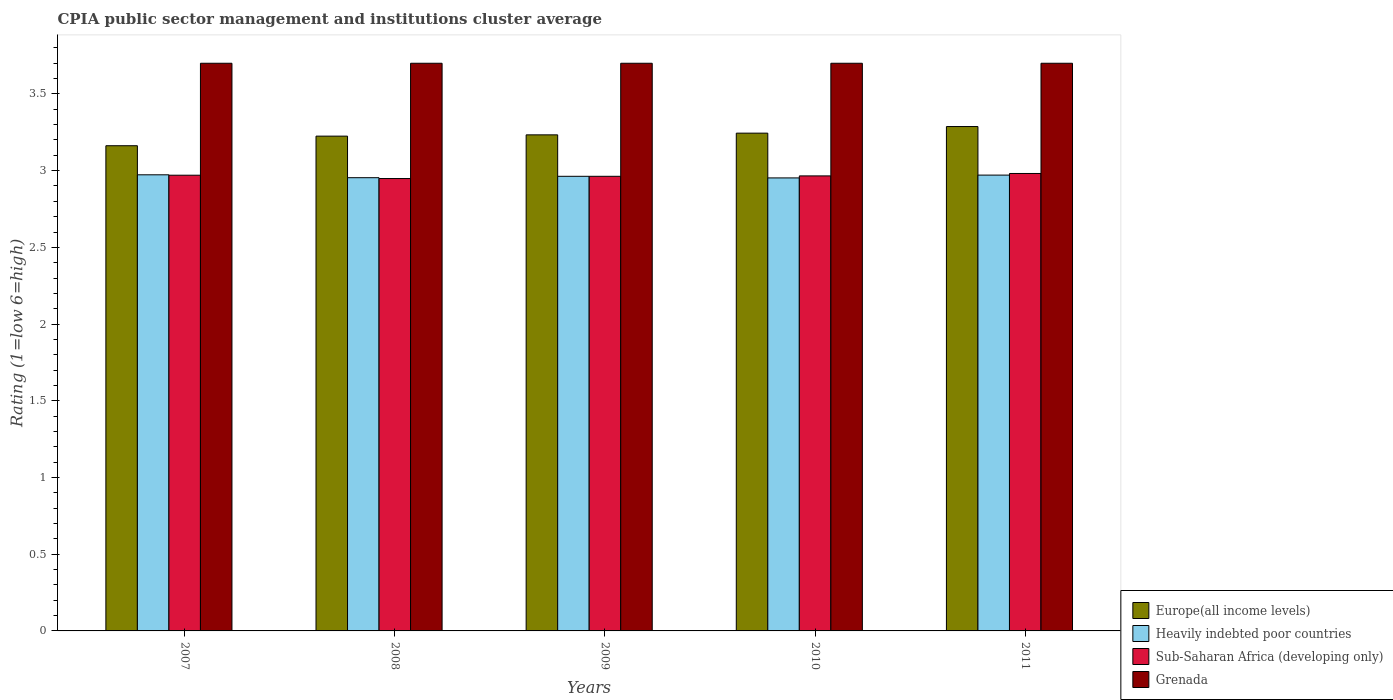How many different coloured bars are there?
Provide a short and direct response. 4. How many groups of bars are there?
Provide a short and direct response. 5. How many bars are there on the 3rd tick from the left?
Your response must be concise. 4. How many bars are there on the 3rd tick from the right?
Provide a succinct answer. 4. In how many cases, is the number of bars for a given year not equal to the number of legend labels?
Offer a terse response. 0. What is the CPIA rating in Europe(all income levels) in 2008?
Provide a short and direct response. 3.23. Across all years, what is the maximum CPIA rating in Sub-Saharan Africa (developing only)?
Keep it short and to the point. 2.98. Across all years, what is the minimum CPIA rating in Heavily indebted poor countries?
Ensure brevity in your answer.  2.95. In which year was the CPIA rating in Sub-Saharan Africa (developing only) maximum?
Your answer should be very brief. 2011. What is the total CPIA rating in Europe(all income levels) in the graph?
Your answer should be very brief. 16.15. What is the difference between the CPIA rating in Grenada in 2007 and the CPIA rating in Europe(all income levels) in 2009?
Your answer should be compact. 0.47. What is the average CPIA rating in Heavily indebted poor countries per year?
Offer a very short reply. 2.96. In the year 2009, what is the difference between the CPIA rating in Sub-Saharan Africa (developing only) and CPIA rating in Europe(all income levels)?
Offer a terse response. -0.27. Is the CPIA rating in Grenada in 2007 less than that in 2011?
Provide a succinct answer. No. Is the difference between the CPIA rating in Sub-Saharan Africa (developing only) in 2007 and 2009 greater than the difference between the CPIA rating in Europe(all income levels) in 2007 and 2009?
Ensure brevity in your answer.  Yes. What is the difference between the highest and the second highest CPIA rating in Sub-Saharan Africa (developing only)?
Keep it short and to the point. 0.01. What is the difference between the highest and the lowest CPIA rating in Grenada?
Offer a terse response. 0. In how many years, is the CPIA rating in Europe(all income levels) greater than the average CPIA rating in Europe(all income levels) taken over all years?
Offer a terse response. 3. Is it the case that in every year, the sum of the CPIA rating in Heavily indebted poor countries and CPIA rating in Sub-Saharan Africa (developing only) is greater than the sum of CPIA rating in Europe(all income levels) and CPIA rating in Grenada?
Make the answer very short. No. What does the 4th bar from the left in 2008 represents?
Make the answer very short. Grenada. What does the 1st bar from the right in 2008 represents?
Give a very brief answer. Grenada. Is it the case that in every year, the sum of the CPIA rating in Grenada and CPIA rating in Europe(all income levels) is greater than the CPIA rating in Sub-Saharan Africa (developing only)?
Provide a succinct answer. Yes. How many years are there in the graph?
Your answer should be very brief. 5. What is the difference between two consecutive major ticks on the Y-axis?
Make the answer very short. 0.5. How are the legend labels stacked?
Give a very brief answer. Vertical. What is the title of the graph?
Keep it short and to the point. CPIA public sector management and institutions cluster average. Does "OECD members" appear as one of the legend labels in the graph?
Provide a short and direct response. No. What is the label or title of the X-axis?
Offer a terse response. Years. What is the label or title of the Y-axis?
Ensure brevity in your answer.  Rating (1=low 6=high). What is the Rating (1=low 6=high) in Europe(all income levels) in 2007?
Your answer should be compact. 3.16. What is the Rating (1=low 6=high) in Heavily indebted poor countries in 2007?
Your answer should be compact. 2.97. What is the Rating (1=low 6=high) in Sub-Saharan Africa (developing only) in 2007?
Provide a succinct answer. 2.97. What is the Rating (1=low 6=high) in Grenada in 2007?
Your response must be concise. 3.7. What is the Rating (1=low 6=high) of Europe(all income levels) in 2008?
Offer a very short reply. 3.23. What is the Rating (1=low 6=high) of Heavily indebted poor countries in 2008?
Ensure brevity in your answer.  2.95. What is the Rating (1=low 6=high) of Sub-Saharan Africa (developing only) in 2008?
Your answer should be compact. 2.95. What is the Rating (1=low 6=high) of Europe(all income levels) in 2009?
Ensure brevity in your answer.  3.23. What is the Rating (1=low 6=high) in Heavily indebted poor countries in 2009?
Provide a short and direct response. 2.96. What is the Rating (1=low 6=high) of Sub-Saharan Africa (developing only) in 2009?
Give a very brief answer. 2.96. What is the Rating (1=low 6=high) of Grenada in 2009?
Keep it short and to the point. 3.7. What is the Rating (1=low 6=high) of Europe(all income levels) in 2010?
Provide a succinct answer. 3.24. What is the Rating (1=low 6=high) of Heavily indebted poor countries in 2010?
Your response must be concise. 2.95. What is the Rating (1=low 6=high) of Sub-Saharan Africa (developing only) in 2010?
Provide a succinct answer. 2.97. What is the Rating (1=low 6=high) of Europe(all income levels) in 2011?
Your response must be concise. 3.29. What is the Rating (1=low 6=high) of Heavily indebted poor countries in 2011?
Offer a terse response. 2.97. What is the Rating (1=low 6=high) of Sub-Saharan Africa (developing only) in 2011?
Make the answer very short. 2.98. What is the Rating (1=low 6=high) in Grenada in 2011?
Ensure brevity in your answer.  3.7. Across all years, what is the maximum Rating (1=low 6=high) in Europe(all income levels)?
Make the answer very short. 3.29. Across all years, what is the maximum Rating (1=low 6=high) in Heavily indebted poor countries?
Provide a short and direct response. 2.97. Across all years, what is the maximum Rating (1=low 6=high) in Sub-Saharan Africa (developing only)?
Ensure brevity in your answer.  2.98. Across all years, what is the minimum Rating (1=low 6=high) of Europe(all income levels)?
Ensure brevity in your answer.  3.16. Across all years, what is the minimum Rating (1=low 6=high) of Heavily indebted poor countries?
Ensure brevity in your answer.  2.95. Across all years, what is the minimum Rating (1=low 6=high) of Sub-Saharan Africa (developing only)?
Your response must be concise. 2.95. Across all years, what is the minimum Rating (1=low 6=high) in Grenada?
Ensure brevity in your answer.  3.7. What is the total Rating (1=low 6=high) of Europe(all income levels) in the graph?
Give a very brief answer. 16.15. What is the total Rating (1=low 6=high) of Heavily indebted poor countries in the graph?
Offer a terse response. 14.81. What is the total Rating (1=low 6=high) of Sub-Saharan Africa (developing only) in the graph?
Keep it short and to the point. 14.83. What is the difference between the Rating (1=low 6=high) of Europe(all income levels) in 2007 and that in 2008?
Your answer should be very brief. -0.06. What is the difference between the Rating (1=low 6=high) in Heavily indebted poor countries in 2007 and that in 2008?
Provide a succinct answer. 0.02. What is the difference between the Rating (1=low 6=high) of Sub-Saharan Africa (developing only) in 2007 and that in 2008?
Provide a succinct answer. 0.02. What is the difference between the Rating (1=low 6=high) of Grenada in 2007 and that in 2008?
Keep it short and to the point. 0. What is the difference between the Rating (1=low 6=high) of Europe(all income levels) in 2007 and that in 2009?
Provide a succinct answer. -0.07. What is the difference between the Rating (1=low 6=high) of Heavily indebted poor countries in 2007 and that in 2009?
Provide a short and direct response. 0.01. What is the difference between the Rating (1=low 6=high) in Sub-Saharan Africa (developing only) in 2007 and that in 2009?
Provide a succinct answer. 0.01. What is the difference between the Rating (1=low 6=high) in Grenada in 2007 and that in 2009?
Make the answer very short. 0. What is the difference between the Rating (1=low 6=high) of Europe(all income levels) in 2007 and that in 2010?
Provide a short and direct response. -0.08. What is the difference between the Rating (1=low 6=high) in Heavily indebted poor countries in 2007 and that in 2010?
Give a very brief answer. 0.02. What is the difference between the Rating (1=low 6=high) of Sub-Saharan Africa (developing only) in 2007 and that in 2010?
Offer a very short reply. 0. What is the difference between the Rating (1=low 6=high) in Grenada in 2007 and that in 2010?
Provide a short and direct response. 0. What is the difference between the Rating (1=low 6=high) in Europe(all income levels) in 2007 and that in 2011?
Offer a very short reply. -0.12. What is the difference between the Rating (1=low 6=high) of Heavily indebted poor countries in 2007 and that in 2011?
Provide a short and direct response. 0. What is the difference between the Rating (1=low 6=high) in Sub-Saharan Africa (developing only) in 2007 and that in 2011?
Make the answer very short. -0.01. What is the difference between the Rating (1=low 6=high) of Europe(all income levels) in 2008 and that in 2009?
Ensure brevity in your answer.  -0.01. What is the difference between the Rating (1=low 6=high) in Heavily indebted poor countries in 2008 and that in 2009?
Your answer should be compact. -0.01. What is the difference between the Rating (1=low 6=high) in Sub-Saharan Africa (developing only) in 2008 and that in 2009?
Your answer should be very brief. -0.01. What is the difference between the Rating (1=low 6=high) in Grenada in 2008 and that in 2009?
Give a very brief answer. 0. What is the difference between the Rating (1=low 6=high) in Europe(all income levels) in 2008 and that in 2010?
Offer a terse response. -0.02. What is the difference between the Rating (1=low 6=high) of Heavily indebted poor countries in 2008 and that in 2010?
Offer a terse response. 0. What is the difference between the Rating (1=low 6=high) of Sub-Saharan Africa (developing only) in 2008 and that in 2010?
Provide a short and direct response. -0.02. What is the difference between the Rating (1=low 6=high) in Europe(all income levels) in 2008 and that in 2011?
Offer a very short reply. -0.06. What is the difference between the Rating (1=low 6=high) in Heavily indebted poor countries in 2008 and that in 2011?
Ensure brevity in your answer.  -0.02. What is the difference between the Rating (1=low 6=high) in Sub-Saharan Africa (developing only) in 2008 and that in 2011?
Make the answer very short. -0.03. What is the difference between the Rating (1=low 6=high) in Grenada in 2008 and that in 2011?
Provide a succinct answer. 0. What is the difference between the Rating (1=low 6=high) in Europe(all income levels) in 2009 and that in 2010?
Your response must be concise. -0.01. What is the difference between the Rating (1=low 6=high) in Heavily indebted poor countries in 2009 and that in 2010?
Ensure brevity in your answer.  0.01. What is the difference between the Rating (1=low 6=high) in Sub-Saharan Africa (developing only) in 2009 and that in 2010?
Ensure brevity in your answer.  -0. What is the difference between the Rating (1=low 6=high) in Grenada in 2009 and that in 2010?
Ensure brevity in your answer.  0. What is the difference between the Rating (1=low 6=high) in Europe(all income levels) in 2009 and that in 2011?
Offer a terse response. -0.05. What is the difference between the Rating (1=low 6=high) of Heavily indebted poor countries in 2009 and that in 2011?
Keep it short and to the point. -0.01. What is the difference between the Rating (1=low 6=high) of Sub-Saharan Africa (developing only) in 2009 and that in 2011?
Offer a terse response. -0.02. What is the difference between the Rating (1=low 6=high) of Europe(all income levels) in 2010 and that in 2011?
Ensure brevity in your answer.  -0.04. What is the difference between the Rating (1=low 6=high) of Heavily indebted poor countries in 2010 and that in 2011?
Offer a very short reply. -0.02. What is the difference between the Rating (1=low 6=high) of Sub-Saharan Africa (developing only) in 2010 and that in 2011?
Offer a very short reply. -0.02. What is the difference between the Rating (1=low 6=high) of Europe(all income levels) in 2007 and the Rating (1=low 6=high) of Heavily indebted poor countries in 2008?
Offer a very short reply. 0.21. What is the difference between the Rating (1=low 6=high) of Europe(all income levels) in 2007 and the Rating (1=low 6=high) of Sub-Saharan Africa (developing only) in 2008?
Offer a terse response. 0.21. What is the difference between the Rating (1=low 6=high) in Europe(all income levels) in 2007 and the Rating (1=low 6=high) in Grenada in 2008?
Ensure brevity in your answer.  -0.54. What is the difference between the Rating (1=low 6=high) in Heavily indebted poor countries in 2007 and the Rating (1=low 6=high) in Sub-Saharan Africa (developing only) in 2008?
Keep it short and to the point. 0.02. What is the difference between the Rating (1=low 6=high) of Heavily indebted poor countries in 2007 and the Rating (1=low 6=high) of Grenada in 2008?
Give a very brief answer. -0.73. What is the difference between the Rating (1=low 6=high) in Sub-Saharan Africa (developing only) in 2007 and the Rating (1=low 6=high) in Grenada in 2008?
Your answer should be very brief. -0.73. What is the difference between the Rating (1=low 6=high) in Europe(all income levels) in 2007 and the Rating (1=low 6=high) in Heavily indebted poor countries in 2009?
Give a very brief answer. 0.2. What is the difference between the Rating (1=low 6=high) in Europe(all income levels) in 2007 and the Rating (1=low 6=high) in Sub-Saharan Africa (developing only) in 2009?
Provide a short and direct response. 0.2. What is the difference between the Rating (1=low 6=high) of Europe(all income levels) in 2007 and the Rating (1=low 6=high) of Grenada in 2009?
Your answer should be very brief. -0.54. What is the difference between the Rating (1=low 6=high) of Heavily indebted poor countries in 2007 and the Rating (1=low 6=high) of Sub-Saharan Africa (developing only) in 2009?
Your response must be concise. 0.01. What is the difference between the Rating (1=low 6=high) in Heavily indebted poor countries in 2007 and the Rating (1=low 6=high) in Grenada in 2009?
Ensure brevity in your answer.  -0.73. What is the difference between the Rating (1=low 6=high) in Sub-Saharan Africa (developing only) in 2007 and the Rating (1=low 6=high) in Grenada in 2009?
Give a very brief answer. -0.73. What is the difference between the Rating (1=low 6=high) of Europe(all income levels) in 2007 and the Rating (1=low 6=high) of Heavily indebted poor countries in 2010?
Provide a succinct answer. 0.21. What is the difference between the Rating (1=low 6=high) of Europe(all income levels) in 2007 and the Rating (1=low 6=high) of Sub-Saharan Africa (developing only) in 2010?
Offer a very short reply. 0.2. What is the difference between the Rating (1=low 6=high) of Europe(all income levels) in 2007 and the Rating (1=low 6=high) of Grenada in 2010?
Your response must be concise. -0.54. What is the difference between the Rating (1=low 6=high) in Heavily indebted poor countries in 2007 and the Rating (1=low 6=high) in Sub-Saharan Africa (developing only) in 2010?
Give a very brief answer. 0.01. What is the difference between the Rating (1=low 6=high) in Heavily indebted poor countries in 2007 and the Rating (1=low 6=high) in Grenada in 2010?
Your response must be concise. -0.73. What is the difference between the Rating (1=low 6=high) of Sub-Saharan Africa (developing only) in 2007 and the Rating (1=low 6=high) of Grenada in 2010?
Your answer should be very brief. -0.73. What is the difference between the Rating (1=low 6=high) of Europe(all income levels) in 2007 and the Rating (1=low 6=high) of Heavily indebted poor countries in 2011?
Ensure brevity in your answer.  0.19. What is the difference between the Rating (1=low 6=high) of Europe(all income levels) in 2007 and the Rating (1=low 6=high) of Sub-Saharan Africa (developing only) in 2011?
Provide a short and direct response. 0.18. What is the difference between the Rating (1=low 6=high) in Europe(all income levels) in 2007 and the Rating (1=low 6=high) in Grenada in 2011?
Give a very brief answer. -0.54. What is the difference between the Rating (1=low 6=high) in Heavily indebted poor countries in 2007 and the Rating (1=low 6=high) in Sub-Saharan Africa (developing only) in 2011?
Offer a terse response. -0.01. What is the difference between the Rating (1=low 6=high) in Heavily indebted poor countries in 2007 and the Rating (1=low 6=high) in Grenada in 2011?
Provide a short and direct response. -0.73. What is the difference between the Rating (1=low 6=high) of Sub-Saharan Africa (developing only) in 2007 and the Rating (1=low 6=high) of Grenada in 2011?
Provide a short and direct response. -0.73. What is the difference between the Rating (1=low 6=high) in Europe(all income levels) in 2008 and the Rating (1=low 6=high) in Heavily indebted poor countries in 2009?
Offer a very short reply. 0.26. What is the difference between the Rating (1=low 6=high) of Europe(all income levels) in 2008 and the Rating (1=low 6=high) of Sub-Saharan Africa (developing only) in 2009?
Provide a succinct answer. 0.26. What is the difference between the Rating (1=low 6=high) of Europe(all income levels) in 2008 and the Rating (1=low 6=high) of Grenada in 2009?
Keep it short and to the point. -0.47. What is the difference between the Rating (1=low 6=high) in Heavily indebted poor countries in 2008 and the Rating (1=low 6=high) in Sub-Saharan Africa (developing only) in 2009?
Offer a terse response. -0.01. What is the difference between the Rating (1=low 6=high) in Heavily indebted poor countries in 2008 and the Rating (1=low 6=high) in Grenada in 2009?
Your answer should be very brief. -0.75. What is the difference between the Rating (1=low 6=high) of Sub-Saharan Africa (developing only) in 2008 and the Rating (1=low 6=high) of Grenada in 2009?
Make the answer very short. -0.75. What is the difference between the Rating (1=low 6=high) of Europe(all income levels) in 2008 and the Rating (1=low 6=high) of Heavily indebted poor countries in 2010?
Your answer should be very brief. 0.27. What is the difference between the Rating (1=low 6=high) of Europe(all income levels) in 2008 and the Rating (1=low 6=high) of Sub-Saharan Africa (developing only) in 2010?
Keep it short and to the point. 0.26. What is the difference between the Rating (1=low 6=high) of Europe(all income levels) in 2008 and the Rating (1=low 6=high) of Grenada in 2010?
Provide a succinct answer. -0.47. What is the difference between the Rating (1=low 6=high) in Heavily indebted poor countries in 2008 and the Rating (1=low 6=high) in Sub-Saharan Africa (developing only) in 2010?
Keep it short and to the point. -0.01. What is the difference between the Rating (1=low 6=high) in Heavily indebted poor countries in 2008 and the Rating (1=low 6=high) in Grenada in 2010?
Make the answer very short. -0.75. What is the difference between the Rating (1=low 6=high) of Sub-Saharan Africa (developing only) in 2008 and the Rating (1=low 6=high) of Grenada in 2010?
Provide a short and direct response. -0.75. What is the difference between the Rating (1=low 6=high) of Europe(all income levels) in 2008 and the Rating (1=low 6=high) of Heavily indebted poor countries in 2011?
Keep it short and to the point. 0.25. What is the difference between the Rating (1=low 6=high) of Europe(all income levels) in 2008 and the Rating (1=low 6=high) of Sub-Saharan Africa (developing only) in 2011?
Keep it short and to the point. 0.24. What is the difference between the Rating (1=low 6=high) in Europe(all income levels) in 2008 and the Rating (1=low 6=high) in Grenada in 2011?
Provide a short and direct response. -0.47. What is the difference between the Rating (1=low 6=high) in Heavily indebted poor countries in 2008 and the Rating (1=low 6=high) in Sub-Saharan Africa (developing only) in 2011?
Offer a very short reply. -0.03. What is the difference between the Rating (1=low 6=high) of Heavily indebted poor countries in 2008 and the Rating (1=low 6=high) of Grenada in 2011?
Provide a short and direct response. -0.75. What is the difference between the Rating (1=low 6=high) of Sub-Saharan Africa (developing only) in 2008 and the Rating (1=low 6=high) of Grenada in 2011?
Your answer should be very brief. -0.75. What is the difference between the Rating (1=low 6=high) in Europe(all income levels) in 2009 and the Rating (1=low 6=high) in Heavily indebted poor countries in 2010?
Your answer should be compact. 0.28. What is the difference between the Rating (1=low 6=high) of Europe(all income levels) in 2009 and the Rating (1=low 6=high) of Sub-Saharan Africa (developing only) in 2010?
Ensure brevity in your answer.  0.27. What is the difference between the Rating (1=low 6=high) in Europe(all income levels) in 2009 and the Rating (1=low 6=high) in Grenada in 2010?
Your answer should be compact. -0.47. What is the difference between the Rating (1=low 6=high) of Heavily indebted poor countries in 2009 and the Rating (1=low 6=high) of Sub-Saharan Africa (developing only) in 2010?
Give a very brief answer. -0. What is the difference between the Rating (1=low 6=high) in Heavily indebted poor countries in 2009 and the Rating (1=low 6=high) in Grenada in 2010?
Your response must be concise. -0.74. What is the difference between the Rating (1=low 6=high) in Sub-Saharan Africa (developing only) in 2009 and the Rating (1=low 6=high) in Grenada in 2010?
Your answer should be very brief. -0.74. What is the difference between the Rating (1=low 6=high) of Europe(all income levels) in 2009 and the Rating (1=low 6=high) of Heavily indebted poor countries in 2011?
Provide a succinct answer. 0.26. What is the difference between the Rating (1=low 6=high) in Europe(all income levels) in 2009 and the Rating (1=low 6=high) in Sub-Saharan Africa (developing only) in 2011?
Your response must be concise. 0.25. What is the difference between the Rating (1=low 6=high) in Europe(all income levels) in 2009 and the Rating (1=low 6=high) in Grenada in 2011?
Offer a terse response. -0.47. What is the difference between the Rating (1=low 6=high) in Heavily indebted poor countries in 2009 and the Rating (1=low 6=high) in Sub-Saharan Africa (developing only) in 2011?
Make the answer very short. -0.02. What is the difference between the Rating (1=low 6=high) in Heavily indebted poor countries in 2009 and the Rating (1=low 6=high) in Grenada in 2011?
Provide a succinct answer. -0.74. What is the difference between the Rating (1=low 6=high) in Sub-Saharan Africa (developing only) in 2009 and the Rating (1=low 6=high) in Grenada in 2011?
Offer a very short reply. -0.74. What is the difference between the Rating (1=low 6=high) of Europe(all income levels) in 2010 and the Rating (1=low 6=high) of Heavily indebted poor countries in 2011?
Your response must be concise. 0.27. What is the difference between the Rating (1=low 6=high) in Europe(all income levels) in 2010 and the Rating (1=low 6=high) in Sub-Saharan Africa (developing only) in 2011?
Offer a terse response. 0.26. What is the difference between the Rating (1=low 6=high) of Europe(all income levels) in 2010 and the Rating (1=low 6=high) of Grenada in 2011?
Offer a terse response. -0.46. What is the difference between the Rating (1=low 6=high) of Heavily indebted poor countries in 2010 and the Rating (1=low 6=high) of Sub-Saharan Africa (developing only) in 2011?
Your response must be concise. -0.03. What is the difference between the Rating (1=low 6=high) of Heavily indebted poor countries in 2010 and the Rating (1=low 6=high) of Grenada in 2011?
Your answer should be very brief. -0.75. What is the difference between the Rating (1=low 6=high) in Sub-Saharan Africa (developing only) in 2010 and the Rating (1=low 6=high) in Grenada in 2011?
Your response must be concise. -0.73. What is the average Rating (1=low 6=high) of Europe(all income levels) per year?
Give a very brief answer. 3.23. What is the average Rating (1=low 6=high) of Heavily indebted poor countries per year?
Give a very brief answer. 2.96. What is the average Rating (1=low 6=high) of Sub-Saharan Africa (developing only) per year?
Ensure brevity in your answer.  2.97. What is the average Rating (1=low 6=high) in Grenada per year?
Offer a very short reply. 3.7. In the year 2007, what is the difference between the Rating (1=low 6=high) of Europe(all income levels) and Rating (1=low 6=high) of Heavily indebted poor countries?
Keep it short and to the point. 0.19. In the year 2007, what is the difference between the Rating (1=low 6=high) of Europe(all income levels) and Rating (1=low 6=high) of Sub-Saharan Africa (developing only)?
Your answer should be very brief. 0.19. In the year 2007, what is the difference between the Rating (1=low 6=high) in Europe(all income levels) and Rating (1=low 6=high) in Grenada?
Make the answer very short. -0.54. In the year 2007, what is the difference between the Rating (1=low 6=high) of Heavily indebted poor countries and Rating (1=low 6=high) of Sub-Saharan Africa (developing only)?
Your answer should be compact. 0. In the year 2007, what is the difference between the Rating (1=low 6=high) of Heavily indebted poor countries and Rating (1=low 6=high) of Grenada?
Make the answer very short. -0.73. In the year 2007, what is the difference between the Rating (1=low 6=high) in Sub-Saharan Africa (developing only) and Rating (1=low 6=high) in Grenada?
Provide a short and direct response. -0.73. In the year 2008, what is the difference between the Rating (1=low 6=high) of Europe(all income levels) and Rating (1=low 6=high) of Heavily indebted poor countries?
Provide a short and direct response. 0.27. In the year 2008, what is the difference between the Rating (1=low 6=high) of Europe(all income levels) and Rating (1=low 6=high) of Sub-Saharan Africa (developing only)?
Keep it short and to the point. 0.28. In the year 2008, what is the difference between the Rating (1=low 6=high) in Europe(all income levels) and Rating (1=low 6=high) in Grenada?
Keep it short and to the point. -0.47. In the year 2008, what is the difference between the Rating (1=low 6=high) in Heavily indebted poor countries and Rating (1=low 6=high) in Sub-Saharan Africa (developing only)?
Your answer should be very brief. 0.01. In the year 2008, what is the difference between the Rating (1=low 6=high) of Heavily indebted poor countries and Rating (1=low 6=high) of Grenada?
Make the answer very short. -0.75. In the year 2008, what is the difference between the Rating (1=low 6=high) of Sub-Saharan Africa (developing only) and Rating (1=low 6=high) of Grenada?
Offer a terse response. -0.75. In the year 2009, what is the difference between the Rating (1=low 6=high) in Europe(all income levels) and Rating (1=low 6=high) in Heavily indebted poor countries?
Offer a terse response. 0.27. In the year 2009, what is the difference between the Rating (1=low 6=high) in Europe(all income levels) and Rating (1=low 6=high) in Sub-Saharan Africa (developing only)?
Offer a very short reply. 0.27. In the year 2009, what is the difference between the Rating (1=low 6=high) in Europe(all income levels) and Rating (1=low 6=high) in Grenada?
Your answer should be very brief. -0.47. In the year 2009, what is the difference between the Rating (1=low 6=high) of Heavily indebted poor countries and Rating (1=low 6=high) of Sub-Saharan Africa (developing only)?
Ensure brevity in your answer.  0. In the year 2009, what is the difference between the Rating (1=low 6=high) of Heavily indebted poor countries and Rating (1=low 6=high) of Grenada?
Ensure brevity in your answer.  -0.74. In the year 2009, what is the difference between the Rating (1=low 6=high) of Sub-Saharan Africa (developing only) and Rating (1=low 6=high) of Grenada?
Your response must be concise. -0.74. In the year 2010, what is the difference between the Rating (1=low 6=high) of Europe(all income levels) and Rating (1=low 6=high) of Heavily indebted poor countries?
Offer a terse response. 0.29. In the year 2010, what is the difference between the Rating (1=low 6=high) in Europe(all income levels) and Rating (1=low 6=high) in Sub-Saharan Africa (developing only)?
Make the answer very short. 0.28. In the year 2010, what is the difference between the Rating (1=low 6=high) of Europe(all income levels) and Rating (1=low 6=high) of Grenada?
Your answer should be very brief. -0.46. In the year 2010, what is the difference between the Rating (1=low 6=high) in Heavily indebted poor countries and Rating (1=low 6=high) in Sub-Saharan Africa (developing only)?
Ensure brevity in your answer.  -0.01. In the year 2010, what is the difference between the Rating (1=low 6=high) of Heavily indebted poor countries and Rating (1=low 6=high) of Grenada?
Offer a very short reply. -0.75. In the year 2010, what is the difference between the Rating (1=low 6=high) in Sub-Saharan Africa (developing only) and Rating (1=low 6=high) in Grenada?
Your answer should be compact. -0.73. In the year 2011, what is the difference between the Rating (1=low 6=high) of Europe(all income levels) and Rating (1=low 6=high) of Heavily indebted poor countries?
Offer a very short reply. 0.32. In the year 2011, what is the difference between the Rating (1=low 6=high) in Europe(all income levels) and Rating (1=low 6=high) in Sub-Saharan Africa (developing only)?
Offer a terse response. 0.31. In the year 2011, what is the difference between the Rating (1=low 6=high) of Europe(all income levels) and Rating (1=low 6=high) of Grenada?
Your answer should be very brief. -0.41. In the year 2011, what is the difference between the Rating (1=low 6=high) of Heavily indebted poor countries and Rating (1=low 6=high) of Sub-Saharan Africa (developing only)?
Your answer should be very brief. -0.01. In the year 2011, what is the difference between the Rating (1=low 6=high) in Heavily indebted poor countries and Rating (1=low 6=high) in Grenada?
Keep it short and to the point. -0.73. In the year 2011, what is the difference between the Rating (1=low 6=high) of Sub-Saharan Africa (developing only) and Rating (1=low 6=high) of Grenada?
Your answer should be compact. -0.72. What is the ratio of the Rating (1=low 6=high) of Europe(all income levels) in 2007 to that in 2008?
Provide a short and direct response. 0.98. What is the ratio of the Rating (1=low 6=high) in Heavily indebted poor countries in 2007 to that in 2008?
Provide a succinct answer. 1.01. What is the ratio of the Rating (1=low 6=high) in Sub-Saharan Africa (developing only) in 2007 to that in 2008?
Your response must be concise. 1.01. What is the ratio of the Rating (1=low 6=high) in Europe(all income levels) in 2007 to that in 2009?
Offer a very short reply. 0.98. What is the ratio of the Rating (1=low 6=high) of Sub-Saharan Africa (developing only) in 2007 to that in 2009?
Ensure brevity in your answer.  1. What is the ratio of the Rating (1=low 6=high) of Grenada in 2007 to that in 2009?
Make the answer very short. 1. What is the ratio of the Rating (1=low 6=high) of Europe(all income levels) in 2007 to that in 2010?
Your response must be concise. 0.97. What is the ratio of the Rating (1=low 6=high) in Heavily indebted poor countries in 2007 to that in 2010?
Offer a very short reply. 1.01. What is the ratio of the Rating (1=low 6=high) in Sub-Saharan Africa (developing only) in 2007 to that in 2010?
Keep it short and to the point. 1. What is the ratio of the Rating (1=low 6=high) in Europe(all income levels) in 2007 to that in 2011?
Offer a terse response. 0.96. What is the ratio of the Rating (1=low 6=high) of Heavily indebted poor countries in 2007 to that in 2011?
Provide a short and direct response. 1. What is the ratio of the Rating (1=low 6=high) of Sub-Saharan Africa (developing only) in 2007 to that in 2011?
Offer a terse response. 1. What is the ratio of the Rating (1=low 6=high) of Europe(all income levels) in 2008 to that in 2009?
Offer a terse response. 1. What is the ratio of the Rating (1=low 6=high) in Heavily indebted poor countries in 2008 to that in 2009?
Offer a very short reply. 1. What is the ratio of the Rating (1=low 6=high) of Sub-Saharan Africa (developing only) in 2008 to that in 2009?
Provide a succinct answer. 1. What is the ratio of the Rating (1=low 6=high) in Grenada in 2008 to that in 2009?
Your answer should be compact. 1. What is the ratio of the Rating (1=low 6=high) of Europe(all income levels) in 2008 to that in 2010?
Your response must be concise. 0.99. What is the ratio of the Rating (1=low 6=high) of Sub-Saharan Africa (developing only) in 2008 to that in 2010?
Ensure brevity in your answer.  0.99. What is the ratio of the Rating (1=low 6=high) of Grenada in 2008 to that in 2010?
Keep it short and to the point. 1. What is the ratio of the Rating (1=low 6=high) in Europe(all income levels) in 2008 to that in 2011?
Ensure brevity in your answer.  0.98. What is the ratio of the Rating (1=low 6=high) of Grenada in 2008 to that in 2011?
Give a very brief answer. 1. What is the ratio of the Rating (1=low 6=high) in Europe(all income levels) in 2009 to that in 2010?
Your response must be concise. 1. What is the ratio of the Rating (1=low 6=high) of Heavily indebted poor countries in 2009 to that in 2010?
Make the answer very short. 1. What is the ratio of the Rating (1=low 6=high) of Sub-Saharan Africa (developing only) in 2009 to that in 2010?
Your answer should be compact. 1. What is the ratio of the Rating (1=low 6=high) of Grenada in 2009 to that in 2010?
Offer a terse response. 1. What is the ratio of the Rating (1=low 6=high) in Europe(all income levels) in 2009 to that in 2011?
Your response must be concise. 0.98. What is the ratio of the Rating (1=low 6=high) in Sub-Saharan Africa (developing only) in 2009 to that in 2011?
Offer a very short reply. 0.99. What is the ratio of the Rating (1=low 6=high) in Grenada in 2009 to that in 2011?
Your answer should be very brief. 1. What is the ratio of the Rating (1=low 6=high) of Europe(all income levels) in 2010 to that in 2011?
Provide a short and direct response. 0.99. What is the ratio of the Rating (1=low 6=high) in Heavily indebted poor countries in 2010 to that in 2011?
Your response must be concise. 0.99. What is the ratio of the Rating (1=low 6=high) of Grenada in 2010 to that in 2011?
Your response must be concise. 1. What is the difference between the highest and the second highest Rating (1=low 6=high) in Europe(all income levels)?
Provide a succinct answer. 0.04. What is the difference between the highest and the second highest Rating (1=low 6=high) in Heavily indebted poor countries?
Make the answer very short. 0. What is the difference between the highest and the second highest Rating (1=low 6=high) of Sub-Saharan Africa (developing only)?
Your answer should be very brief. 0.01. What is the difference between the highest and the second highest Rating (1=low 6=high) in Grenada?
Ensure brevity in your answer.  0. What is the difference between the highest and the lowest Rating (1=low 6=high) of Europe(all income levels)?
Keep it short and to the point. 0.12. What is the difference between the highest and the lowest Rating (1=low 6=high) of Heavily indebted poor countries?
Your answer should be compact. 0.02. What is the difference between the highest and the lowest Rating (1=low 6=high) of Sub-Saharan Africa (developing only)?
Your answer should be compact. 0.03. What is the difference between the highest and the lowest Rating (1=low 6=high) in Grenada?
Your answer should be very brief. 0. 